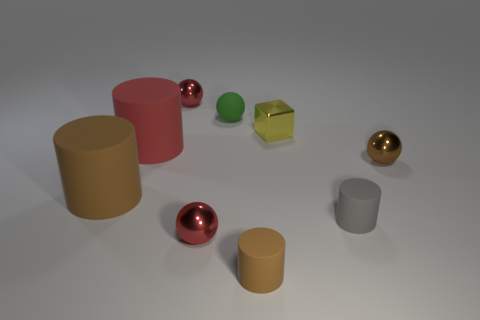Is there anything else that is the same size as the block?
Your answer should be very brief. Yes. What size is the brown object that is made of the same material as the tiny yellow object?
Ensure brevity in your answer.  Small. What number of objects are small matte cylinders that are on the right side of the tiny yellow shiny object or tiny balls that are in front of the gray cylinder?
Offer a very short reply. 2. Is the size of the brown thing in front of the gray rubber cylinder the same as the large brown matte cylinder?
Make the answer very short. No. The large rubber cylinder in front of the red matte cylinder is what color?
Provide a succinct answer. Brown. The other large rubber thing that is the same shape as the large brown matte object is what color?
Ensure brevity in your answer.  Red. There is a small brown thing that is on the right side of the tiny matte cylinder that is on the right side of the block; what number of small objects are in front of it?
Your answer should be compact. 3. Is there any other thing that has the same material as the red cylinder?
Offer a terse response. Yes. Is the number of small brown metal spheres to the left of the tiny brown cylinder less than the number of yellow shiny blocks?
Your response must be concise. Yes. Do the block and the tiny matte sphere have the same color?
Offer a terse response. No. 